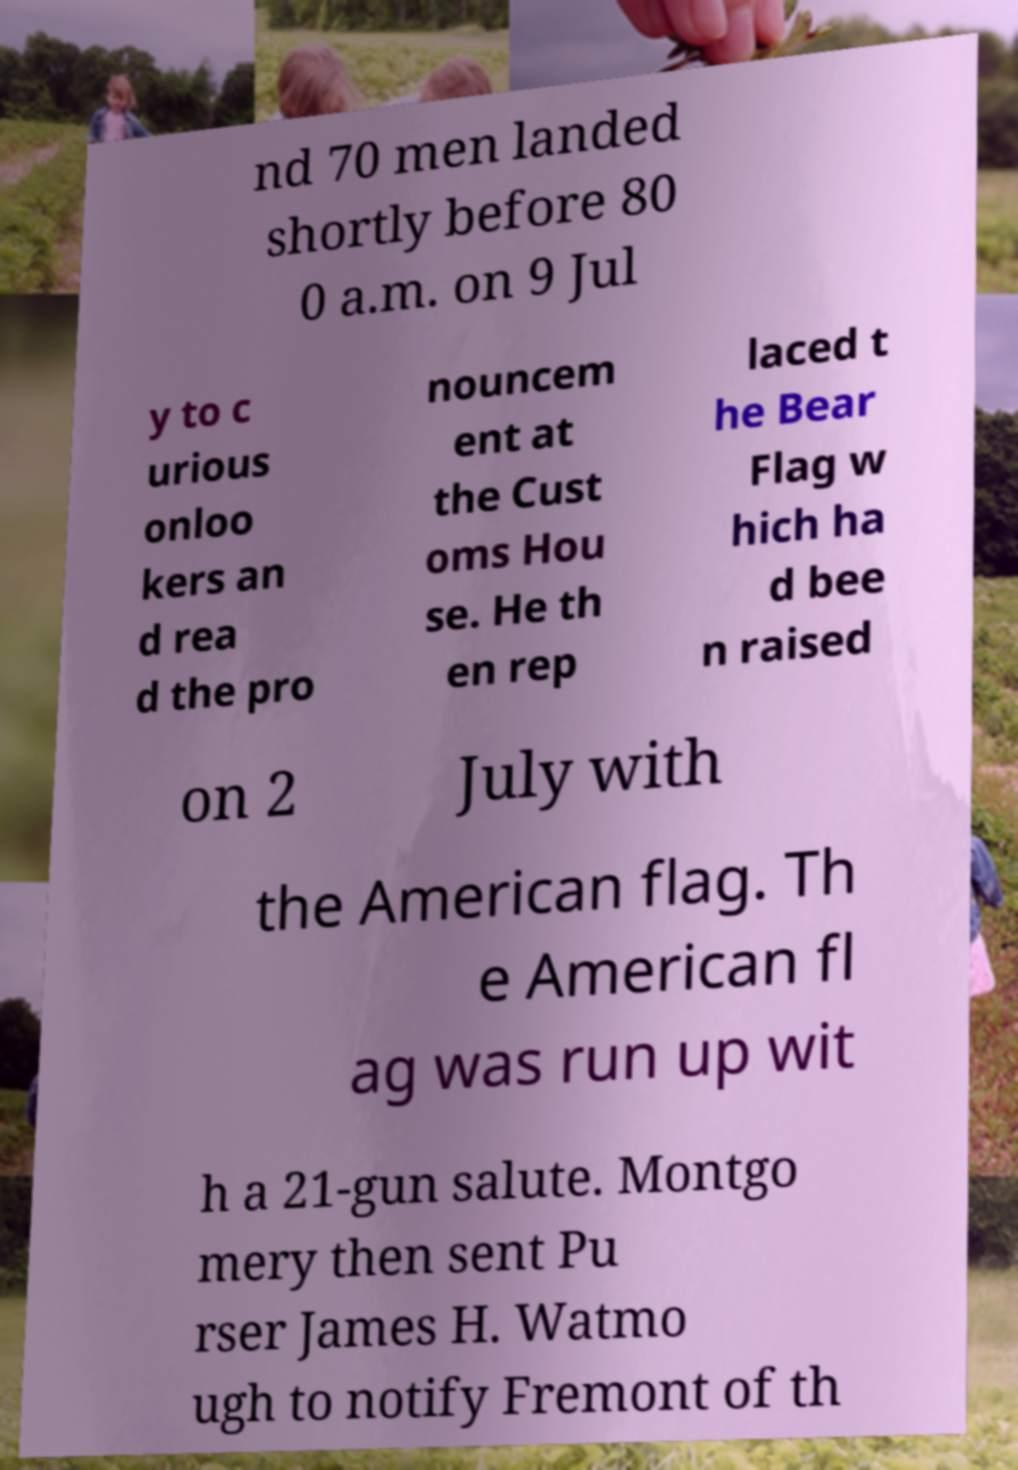Could you assist in decoding the text presented in this image and type it out clearly? nd 70 men landed shortly before 80 0 a.m. on 9 Jul y to c urious onloo kers an d rea d the pro nouncem ent at the Cust oms Hou se. He th en rep laced t he Bear Flag w hich ha d bee n raised on 2 July with the American flag. Th e American fl ag was run up wit h a 21-gun salute. Montgo mery then sent Pu rser James H. Watmo ugh to notify Fremont of th 